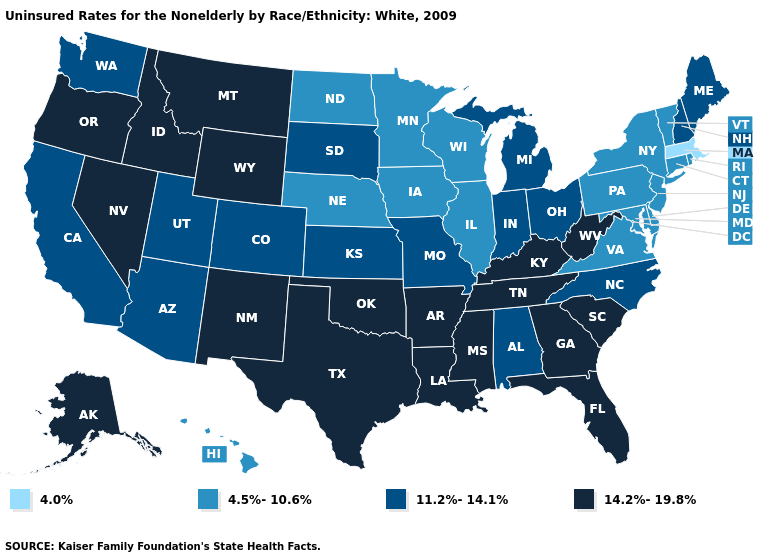Which states have the lowest value in the Northeast?
Be succinct. Massachusetts. What is the highest value in states that border Mississippi?
Write a very short answer. 14.2%-19.8%. Does the map have missing data?
Answer briefly. No. What is the highest value in the South ?
Short answer required. 14.2%-19.8%. Name the states that have a value in the range 4.0%?
Give a very brief answer. Massachusetts. Does Kansas have the lowest value in the MidWest?
Give a very brief answer. No. Does Washington have a lower value than Arkansas?
Write a very short answer. Yes. Does the map have missing data?
Be succinct. No. What is the value of Illinois?
Short answer required. 4.5%-10.6%. Name the states that have a value in the range 4.0%?
Give a very brief answer. Massachusetts. Does Massachusetts have the lowest value in the USA?
Answer briefly. Yes. What is the value of Iowa?
Write a very short answer. 4.5%-10.6%. How many symbols are there in the legend?
Quick response, please. 4. Among the states that border South Carolina , which have the lowest value?
Keep it brief. North Carolina. 